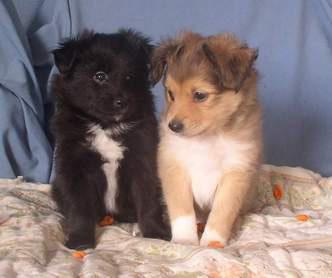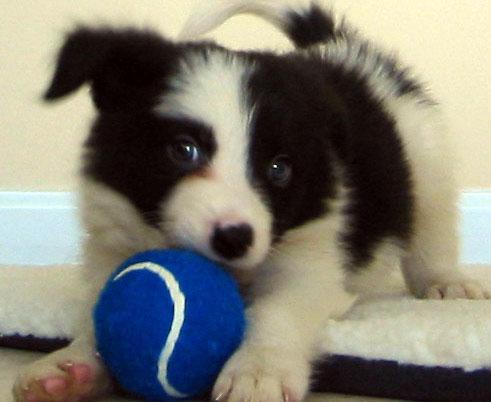The first image is the image on the left, the second image is the image on the right. Assess this claim about the two images: "There are no more than three dogs.". Correct or not? Answer yes or no. Yes. The first image is the image on the left, the second image is the image on the right. Examine the images to the left and right. Is the description "There are at most three dogs." accurate? Answer yes or no. Yes. 